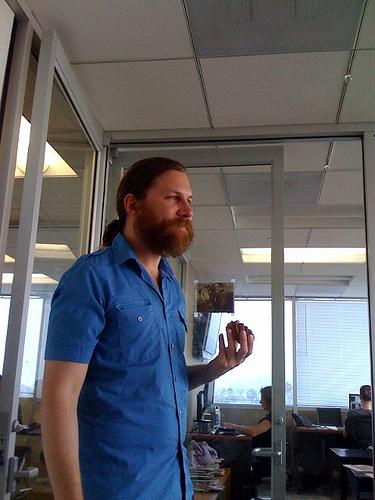What office reprieve does this man avail himself of?

Choices:
A) coffee break
B) airplane building
C) nap
D) filing coffee break 